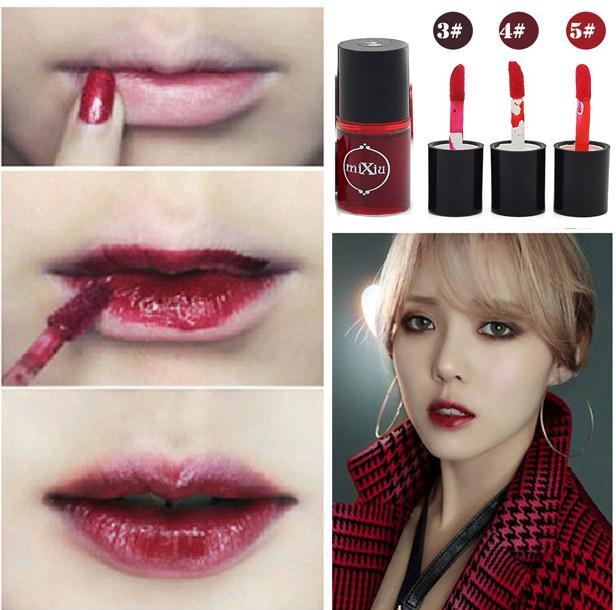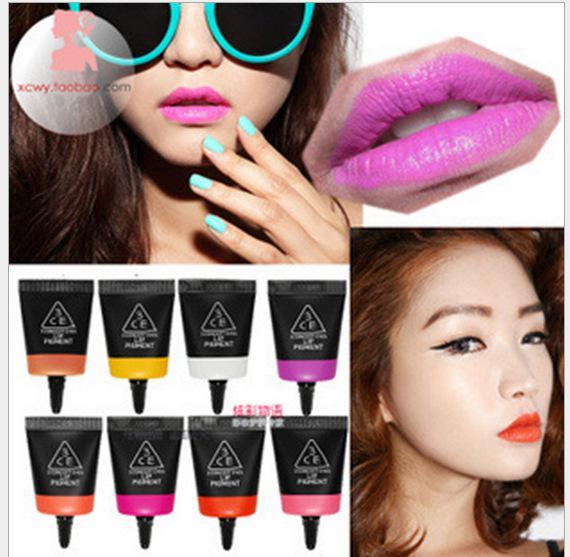The first image is the image on the left, the second image is the image on the right. Considering the images on both sides, is "One image has three lips." valid? Answer yes or no. Yes. 